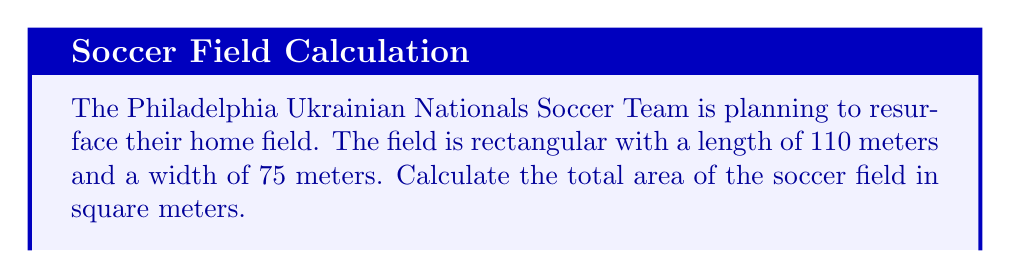Give your solution to this math problem. To calculate the area of a rectangular soccer field, we need to use the formula for the area of a rectangle:

$$A = l \times w$$

Where:
$A$ = Area
$l$ = Length
$w$ = Width

Given:
- Length of the field = 110 meters
- Width of the field = 75 meters

Let's substitute these values into the formula:

$$A = 110 \times 75$$

Now, let's perform the multiplication:

$$A = 8,250$$

Therefore, the total area of the soccer field is 8,250 square meters.
Answer: 8,250 m² 